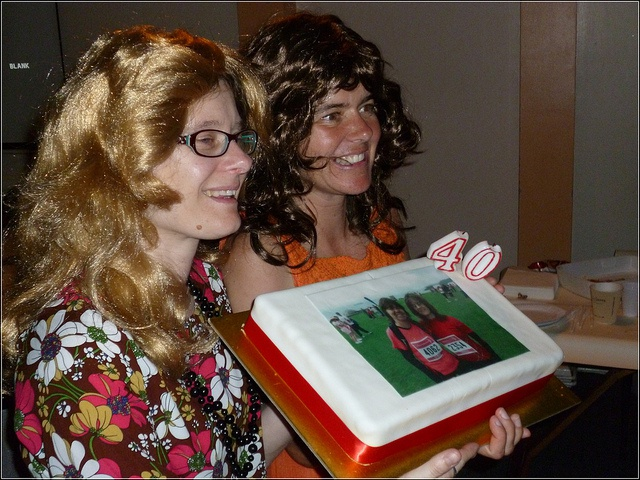Describe the objects in this image and their specific colors. I can see people in black, maroon, and gray tones, cake in black, lightgray, darkgray, and maroon tones, people in black, gray, maroon, and brown tones, book in black, maroon, and gray tones, and cup in black, maroon, and gray tones in this image. 